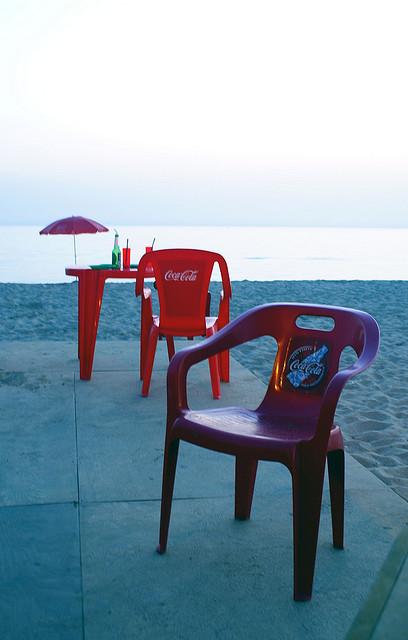What is on the table?
Write a very short answer. Drinks. Where is this setting?
Concise answer only. Beach. What color are the chairs?
Short answer required. Red. 